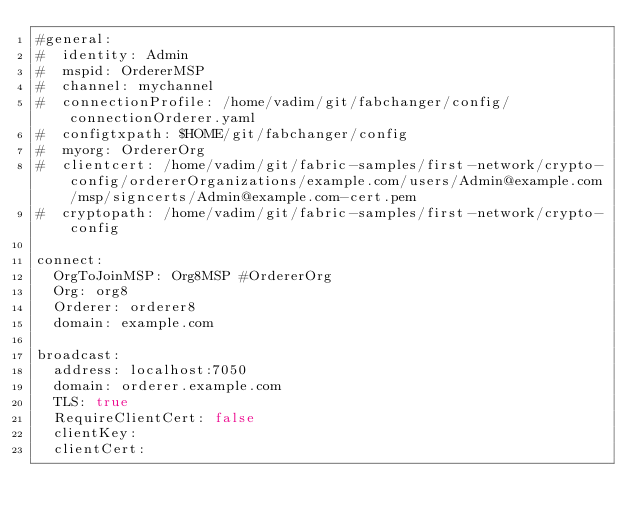<code> <loc_0><loc_0><loc_500><loc_500><_YAML_>#general:
#  identity: Admin
#  mspid: OrdererMSP
#  channel: mychannel
#  connectionProfile: /home/vadim/git/fabchanger/config/connectionOrderer.yaml
#  configtxpath: $HOME/git/fabchanger/config
#  myorg: OrdererOrg
#  clientcert: /home/vadim/git/fabric-samples/first-network/crypto-config/ordererOrganizations/example.com/users/Admin@example.com/msp/signcerts/Admin@example.com-cert.pem
#  cryptopath: /home/vadim/git/fabric-samples/first-network/crypto-config

connect:
  OrgToJoinMSP: Org8MSP #OrdererOrg
  Org: org8
  Orderer: orderer8
  domain: example.com

broadcast:
  address: localhost:7050
  domain: orderer.example.com
  TLS: true
  RequireClientCert: false
  clientKey:
  clientCert:</code> 